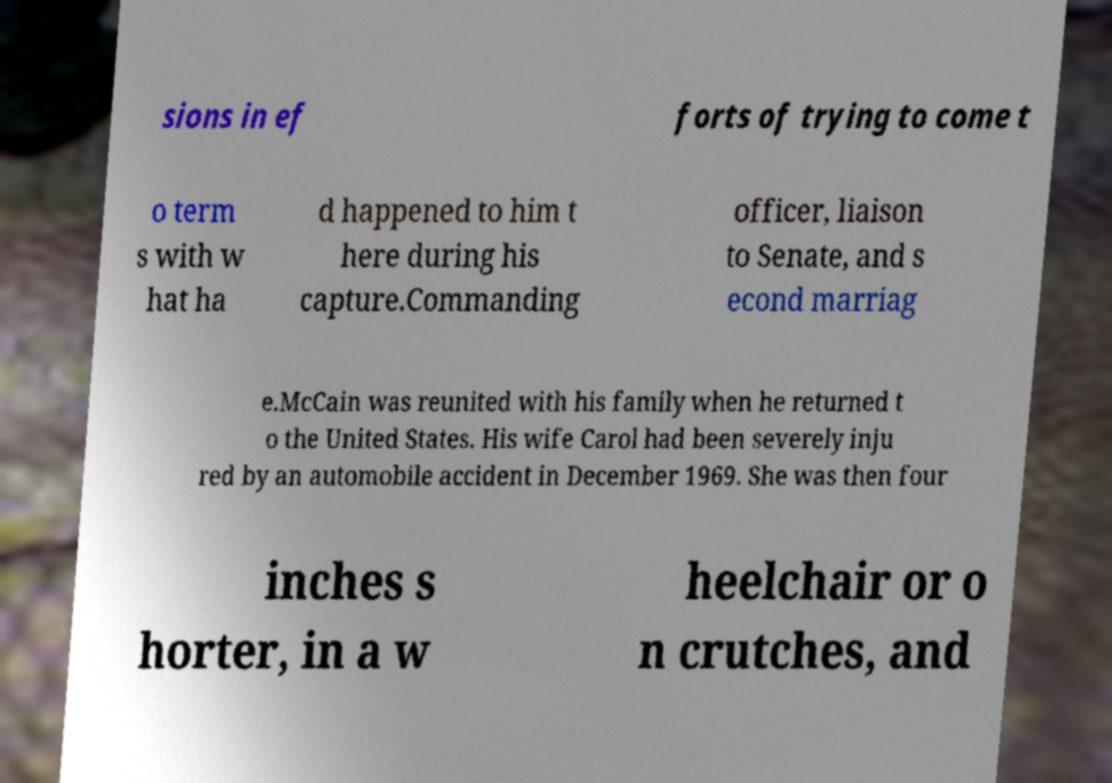I need the written content from this picture converted into text. Can you do that? sions in ef forts of trying to come t o term s with w hat ha d happened to him t here during his capture.Commanding officer, liaison to Senate, and s econd marriag e.McCain was reunited with his family when he returned t o the United States. His wife Carol had been severely inju red by an automobile accident in December 1969. She was then four inches s horter, in a w heelchair or o n crutches, and 